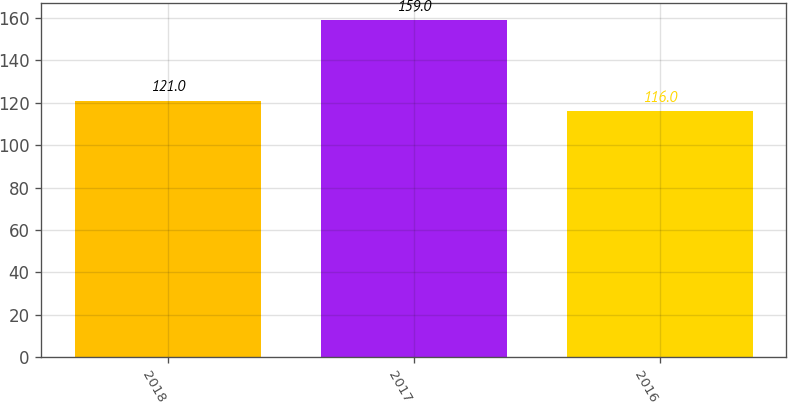Convert chart. <chart><loc_0><loc_0><loc_500><loc_500><bar_chart><fcel>2018<fcel>2017<fcel>2016<nl><fcel>121<fcel>159<fcel>116<nl></chart> 